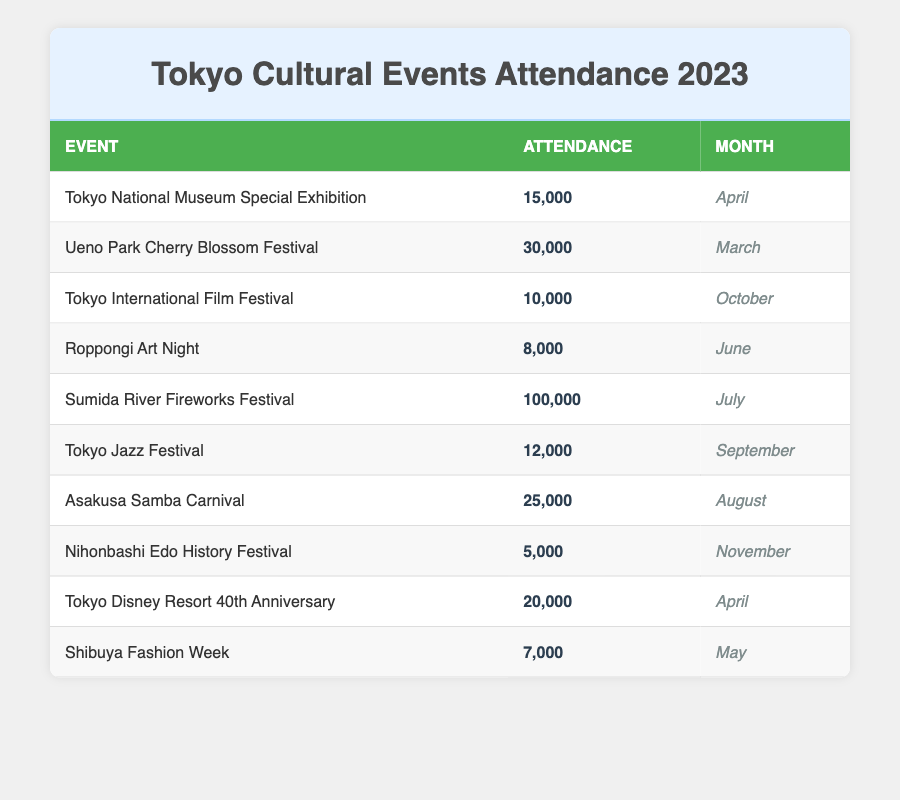What is the event with the highest attendance? By looking at the data in the table, the event with the highest attendance is the "Sumida River Fireworks Festival," which had an attendance of 100,000.
Answer: Sumida River Fireworks Festival How many attendees participated in the Tokyo Jazz Festival? The table directly shows that the Tokyo Jazz Festival had an attendance of 12,000.
Answer: 12,000 Which month had the least attended cultural event, and what was the attendance? The least attended event is the "Nihonbashi Edo History Festival," which took place in November with an attendance of 5,000.
Answer: November, 5,000 What is the total attendance for events in April? In April, there were two events: the "Tokyo National Museum Special Exhibition" with 15,000 attendees and the "Tokyo Disney Resort 40th Anniversary" with 20,000 attendees. The total attendance is 15,000 + 20,000 = 35,000.
Answer: 35,000 Is the Ueno Park Cherry Blossom Festival more attended than the Asakusa Samba Carnival? The Ueno Park Cherry Blossom Festival had an attendance of 30,000, while the Asakusa Samba Carnival had 25,000. Since 30,000 is greater than 25,000, the statement is true.
Answer: Yes What is the average attendance of the events that took place in July and August? The events in July and August are the "Sumida River Fireworks Festival" (attendance 100,000) and the "Asakusa Samba Carnival" (attendance 25,000). The average is (100,000 + 25,000) / 2 = 62,500.
Answer: 62,500 Which two events cumulatively had more than 50,000 attendees? The "Sumida River Fireworks Festival" (100,000) and the "Ueno Park Cherry Blossom Festival" (30,000) combined have an attendance of 130,000, which is greater than 50,000. Thus, they meet the criteria.
Answer: Yes In which month was the Tokyo International Film Festival held? The table specifies that the Tokyo International Film Festival was held in October.
Answer: October 